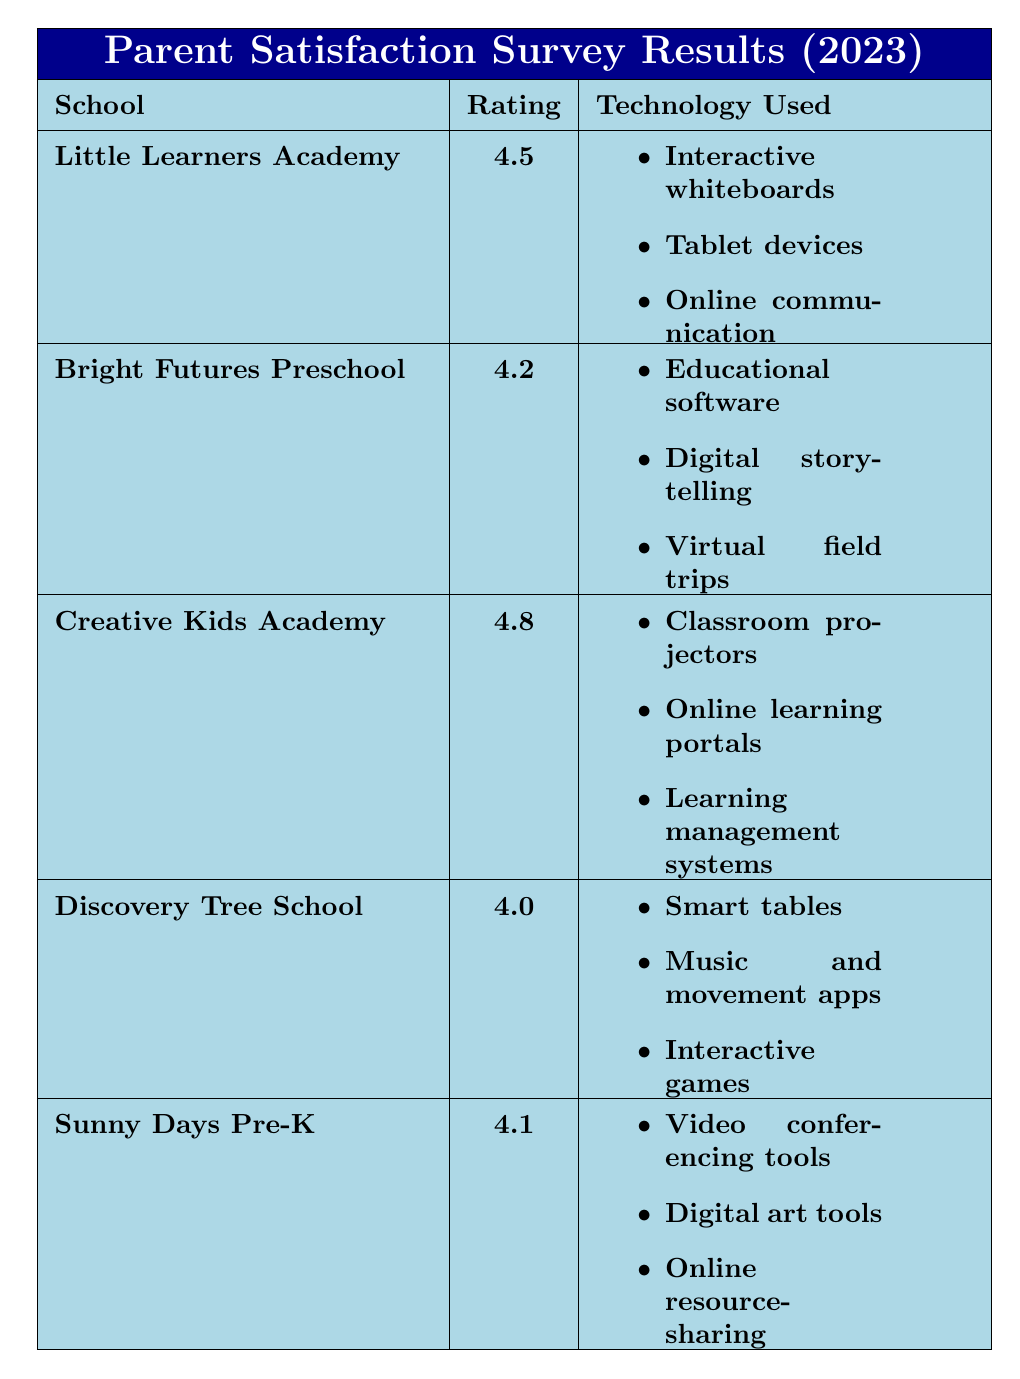What is the highest satisfaction rating among the schools? The table lists the satisfaction ratings for each school. Looking through the ratings, Creative Kids Academy has the highest rating at 4.8.
Answer: 4.8 Which school has the lowest satisfaction rating? By examining the satisfaction ratings in the table, Discovery Tree School has the lowest rating listed at 4.0.
Answer: Discovery Tree School How many different types of technology are used at Bright Futures Preschool? The table outlines the technology used at Bright Futures Preschool and lists three items: educational software, digital storytelling apps, and virtual field trips. Therefore, there are three types.
Answer: 3 What technology is used at Sunny Days Pre-K? The table indicates that Sunny Days Pre-K uses video conferencing tools, digital art tools, and online resource-sharing platforms.
Answer: Video conferencing tools, digital art tools, online resource-sharing platforms What is the average satisfaction rating of all schools? First, add all the satisfaction ratings: 4.5 + 4.2 + 4.8 + 4.0 + 4.1 = 21.6. Then, divide by the number of schools (5), 21.6 / 5 = 4.32.
Answer: 4.32 Is it true that all schools have a satisfaction rating above 4.0? Review the ratings: Little Learners Academy (4.5), Bright Futures Preschool (4.2), Creative Kids Academy (4.8), Discovery Tree School (4.0), and Sunny Days Pre-K (4.1). Since Discovery Tree School exactly meets 4.0, the statement is true.
Answer: Yes How does the satisfaction rating of Little Learners Academy compare to that of Discovery Tree School? Little Learners Academy has a satisfaction rating of 4.5, while Discovery Tree School has a rating of 4.0. The difference is 4.5 - 4.0 = 0.5, meaning Little Learners Academy has a higher rating by 0.5.
Answer: Little Learners Academy is higher by 0.5 Which technology used at Creative Kids Academy is mentioned to enhance engagement? The table states that classroom projectors are used and specifically mentions that they make lessons more engaging.
Answer: Classroom projectors Are virtual field trips used in any other school besides Bright Futures Preschool? The table only mentions virtual field trips under Bright Futures Preschool and does not list them for any other school. Thus, they are not used in any other school.
Answer: No How many technologies listed for Discovery Tree School include hands-on learning? The technologies listed include smart tables (which provide hands-on opportunities), music and movement apps, and interactive games. Therefore, there is one technology that specifically supports hands-on learning.
Answer: 1 Which school received the highest overall parent feedback regarding technology use? Based on qualitative feedback, Creative Kids Academy received positive comments about classroom projectors making lessons engaging and the online portal for tracking progress, indicating a high level of satisfaction.
Answer: Creative Kids Academy 